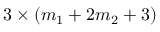<formula> <loc_0><loc_0><loc_500><loc_500>3 \times ( m _ { 1 } + 2 m _ { 2 } + 3 )</formula> 